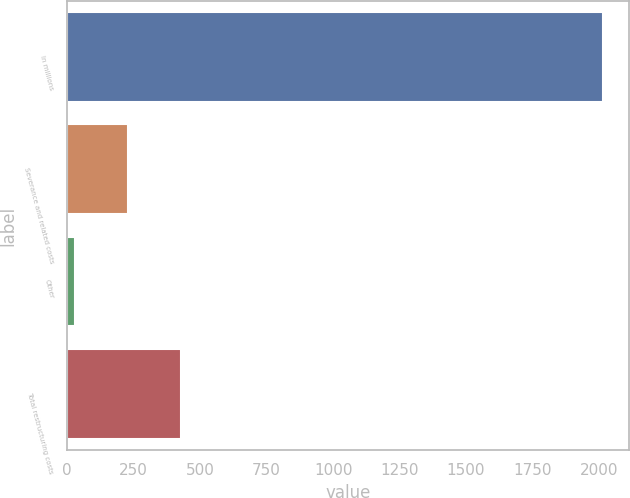Convert chart to OTSL. <chart><loc_0><loc_0><loc_500><loc_500><bar_chart><fcel>In millions<fcel>Severance and related costs<fcel>Other<fcel>Total restructuring costs<nl><fcel>2014<fcel>227.86<fcel>29.4<fcel>426.32<nl></chart> 